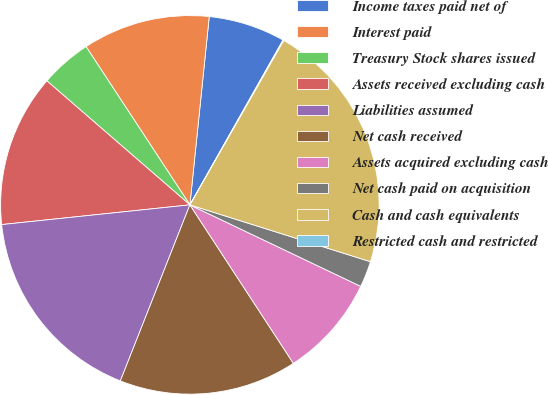Convert chart. <chart><loc_0><loc_0><loc_500><loc_500><pie_chart><fcel>Income taxes paid net of<fcel>Interest paid<fcel>Treasury Stock shares issued<fcel>Assets received excluding cash<fcel>Liabilities assumed<fcel>Net cash received<fcel>Assets acquired excluding cash<fcel>Net cash paid on acquisition<fcel>Cash and cash equivalents<fcel>Restricted cash and restricted<nl><fcel>6.55%<fcel>10.87%<fcel>4.39%<fcel>13.03%<fcel>17.35%<fcel>15.19%<fcel>8.71%<fcel>2.23%<fcel>21.6%<fcel>0.07%<nl></chart> 